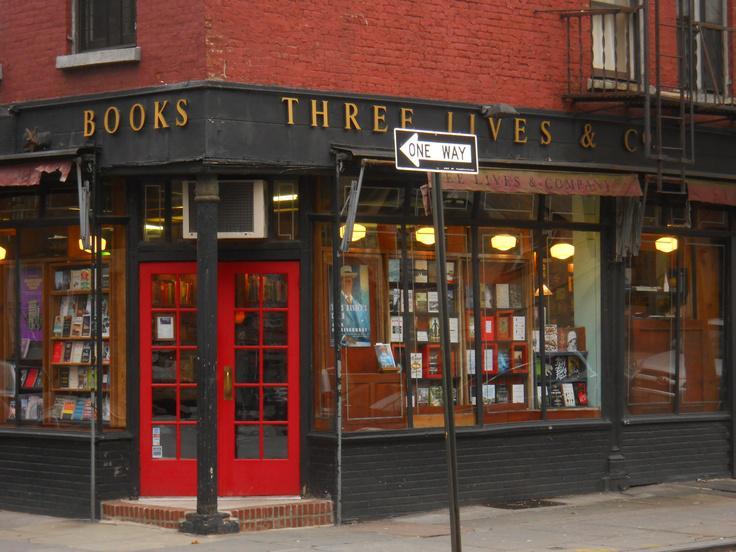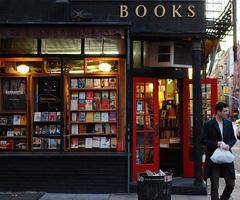The first image is the image on the left, the second image is the image on the right. Examine the images to the left and right. Is the description "At least one person is walking outside of one of the stores." accurate? Answer yes or no. Yes. The first image is the image on the left, the second image is the image on the right. For the images displayed, is the sentence "There is a storefront in each image." factually correct? Answer yes or no. Yes. 